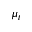<formula> <loc_0><loc_0><loc_500><loc_500>\mu _ { t }</formula> 